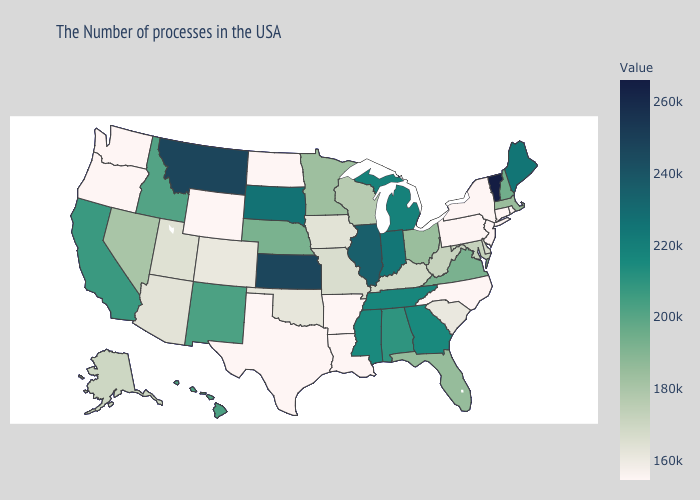Does Texas have the lowest value in the South?
Give a very brief answer. Yes. Which states have the highest value in the USA?
Write a very short answer. Vermont. Which states have the lowest value in the USA?
Short answer required. Rhode Island, Connecticut, New York, New Jersey, Pennsylvania, North Carolina, Louisiana, Arkansas, Texas, North Dakota, Wyoming, Washington, Oregon. Does California have the lowest value in the USA?
Keep it brief. No. Does the map have missing data?
Write a very short answer. No. 